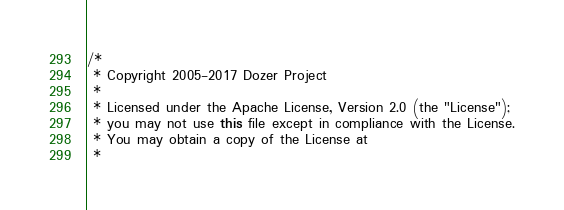<code> <loc_0><loc_0><loc_500><loc_500><_Java_>/*
 * Copyright 2005-2017 Dozer Project
 *
 * Licensed under the Apache License, Version 2.0 (the "License");
 * you may not use this file except in compliance with the License.
 * You may obtain a copy of the License at
 *</code> 